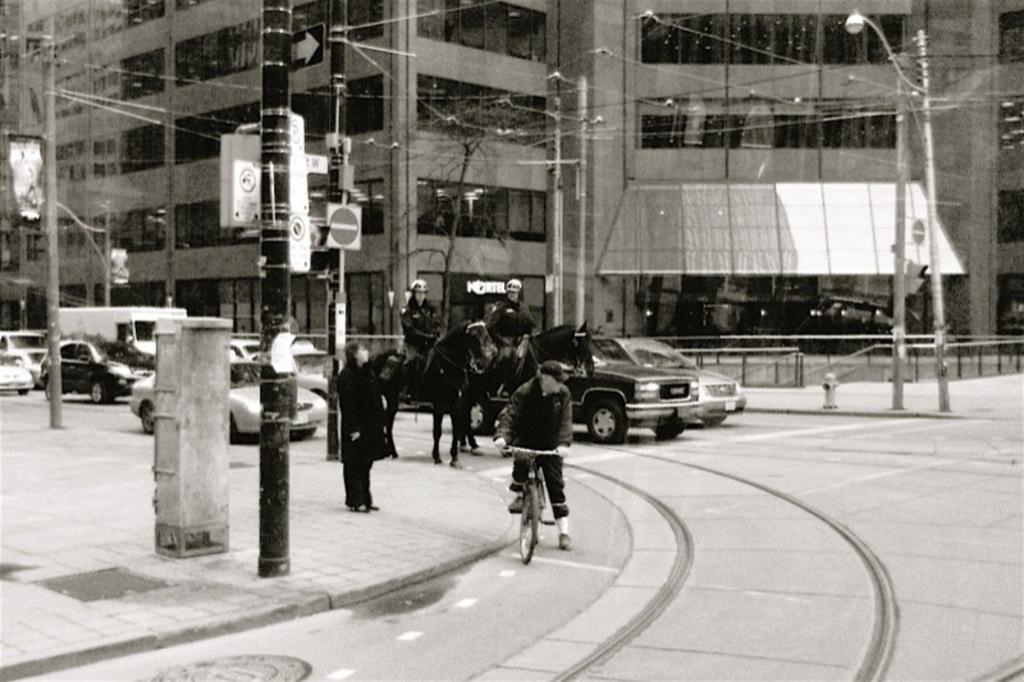Describe this image in one or two sentences. This picture shows few vehicles moving on the road and we see couple of horses riding by men and we see a man riding bicycle and a person standing and we see a building and pole light 